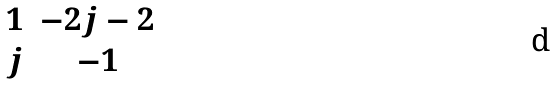Convert formula to latex. <formula><loc_0><loc_0><loc_500><loc_500>\begin{matrix} 1 & - 2 j - 2 \\ j & - 1 \end{matrix}</formula> 